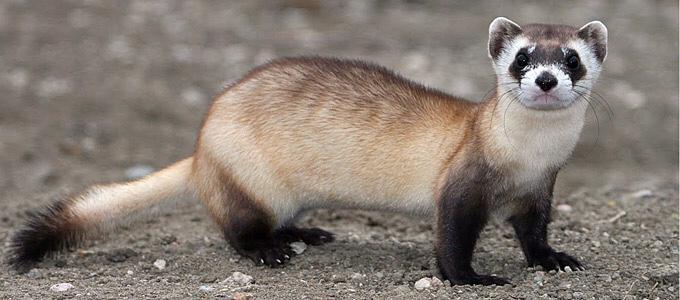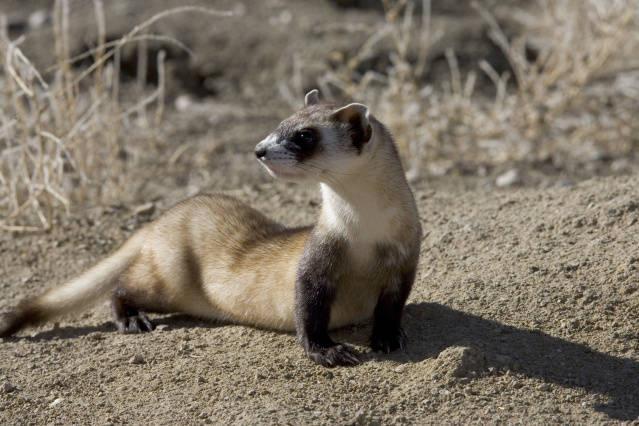The first image is the image on the left, the second image is the image on the right. Analyze the images presented: Is the assertion "One of the weasels is facing left." valid? Answer yes or no. Yes. The first image is the image on the left, the second image is the image on the right. Examine the images to the left and right. Is the description "The ferret is seen coming out of a hole in the image on the right." accurate? Answer yes or no. No. 